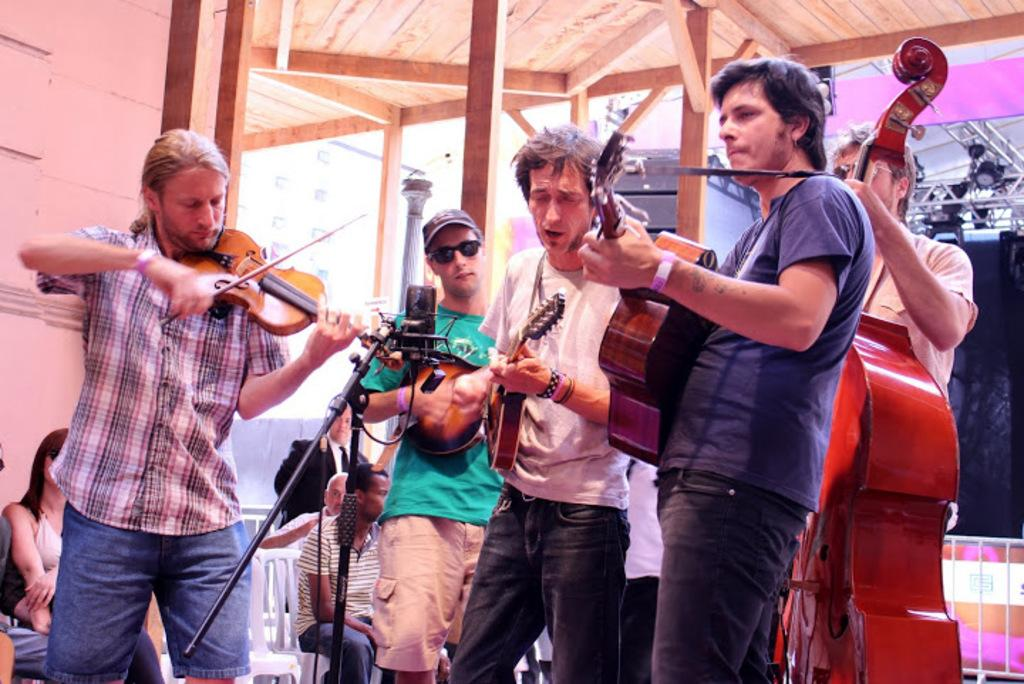What are the people in the image doing? The people in the image are standing and playing musical instruments. What can be seen near the people playing instruments? There are people sitting on chairs in the image. Where is the image set? The image is set on a rooftop. What material is the rooftop made of? The rooftop is made of wood. What color is the paint on the sisters' dresses in the image? There are no sisters or dresses mentioned in the provided facts, and therefore no paint color can be determined. 